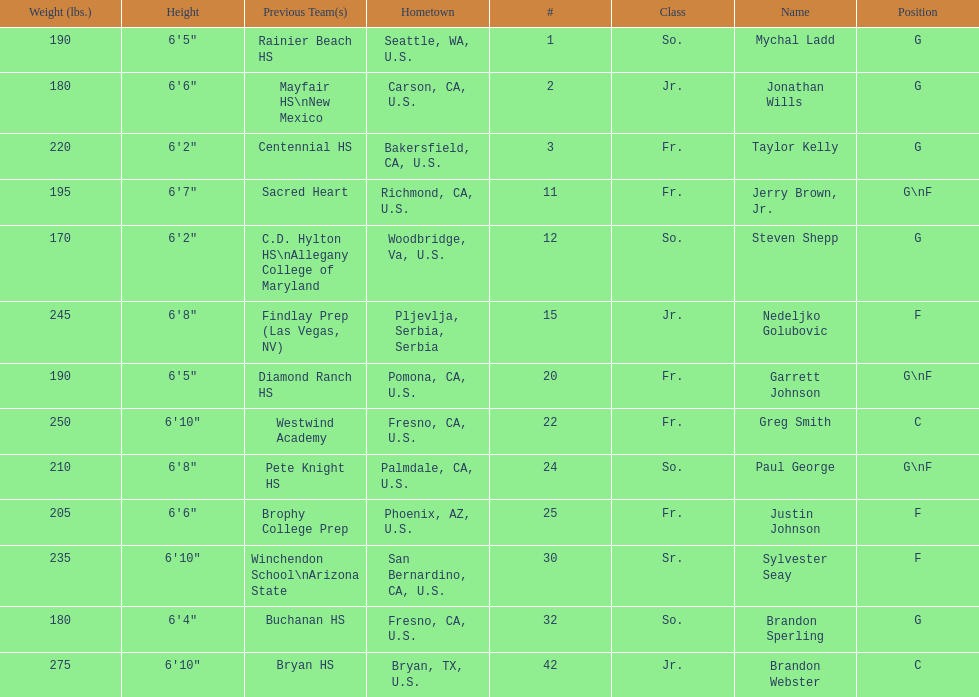Who is the only player not from the u. s.? Nedeljko Golubovic. Write the full table. {'header': ['Weight (lbs.)', 'Height', 'Previous Team(s)', 'Hometown', '#', 'Class', 'Name', 'Position'], 'rows': [['190', '6\'5"', 'Rainier Beach HS', 'Seattle, WA, U.S.', '1', 'So.', 'Mychal Ladd', 'G'], ['180', '6\'6"', 'Mayfair HS\\nNew Mexico', 'Carson, CA, U.S.', '2', 'Jr.', 'Jonathan Wills', 'G'], ['220', '6\'2"', 'Centennial HS', 'Bakersfield, CA, U.S.', '3', 'Fr.', 'Taylor Kelly', 'G'], ['195', '6\'7"', 'Sacred Heart', 'Richmond, CA, U.S.', '11', 'Fr.', 'Jerry Brown, Jr.', 'G\\nF'], ['170', '6\'2"', 'C.D. Hylton HS\\nAllegany College of Maryland', 'Woodbridge, Va, U.S.', '12', 'So.', 'Steven Shepp', 'G'], ['245', '6\'8"', 'Findlay Prep (Las Vegas, NV)', 'Pljevlja, Serbia, Serbia', '15', 'Jr.', 'Nedeljko Golubovic', 'F'], ['190', '6\'5"', 'Diamond Ranch HS', 'Pomona, CA, U.S.', '20', 'Fr.', 'Garrett Johnson', 'G\\nF'], ['250', '6\'10"', 'Westwind Academy', 'Fresno, CA, U.S.', '22', 'Fr.', 'Greg Smith', 'C'], ['210', '6\'8"', 'Pete Knight HS', 'Palmdale, CA, U.S.', '24', 'So.', 'Paul George', 'G\\nF'], ['205', '6\'6"', 'Brophy College Prep', 'Phoenix, AZ, U.S.', '25', 'Fr.', 'Justin Johnson', 'F'], ['235', '6\'10"', 'Winchendon School\\nArizona State', 'San Bernardino, CA, U.S.', '30', 'Sr.', 'Sylvester Seay', 'F'], ['180', '6\'4"', 'Buchanan HS', 'Fresno, CA, U.S.', '32', 'So.', 'Brandon Sperling', 'G'], ['275', '6\'10"', 'Bryan HS', 'Bryan, TX, U.S.', '42', 'Jr.', 'Brandon Webster', 'C']]} 